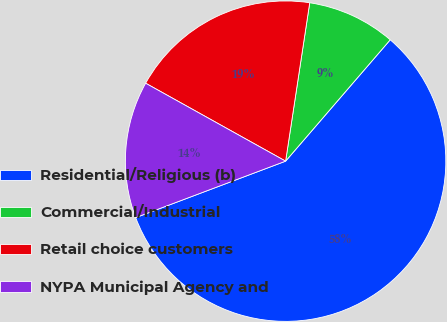<chart> <loc_0><loc_0><loc_500><loc_500><pie_chart><fcel>Residential/Religious (b)<fcel>Commercial/Industrial<fcel>Retail choice customers<fcel>NYPA Municipal Agency and<nl><fcel>57.95%<fcel>8.92%<fcel>19.32%<fcel>13.82%<nl></chart> 